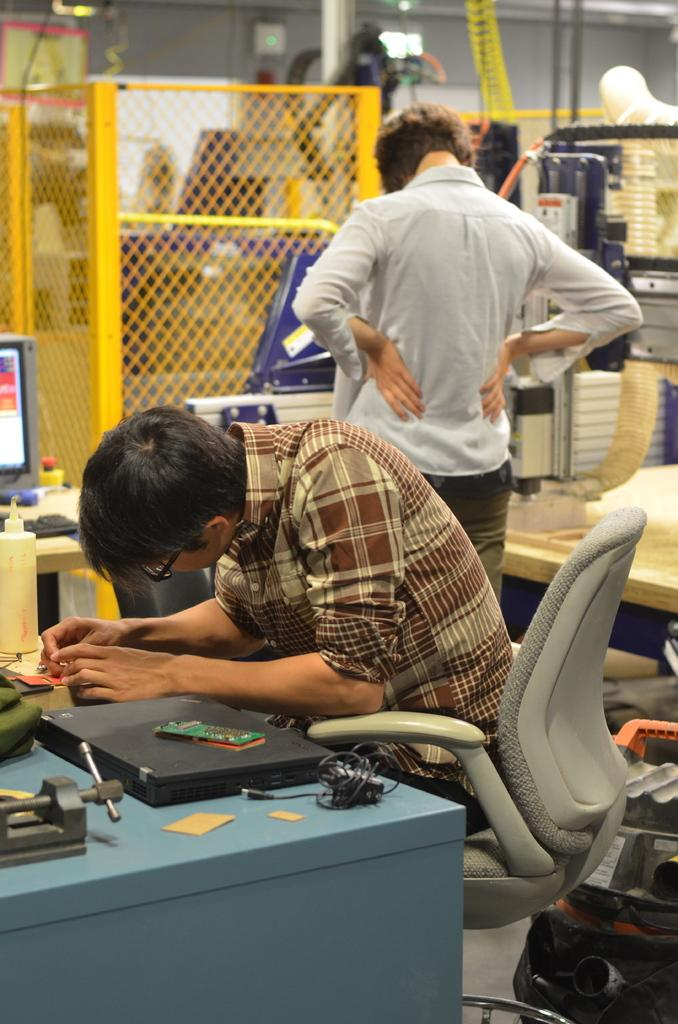What is the man in the image doing? The man is sitting in a chair. What is on the table in the image? There is a laptop, cables, and papers on the table. Can you describe the background of the image? In the background, there is a man, a computer on a table, grills, and pipes visible. How many women are visible in the image? There are no women visible in the image. What type of pin can be seen on the moon in the image? There is no moon or pin present in the image. 